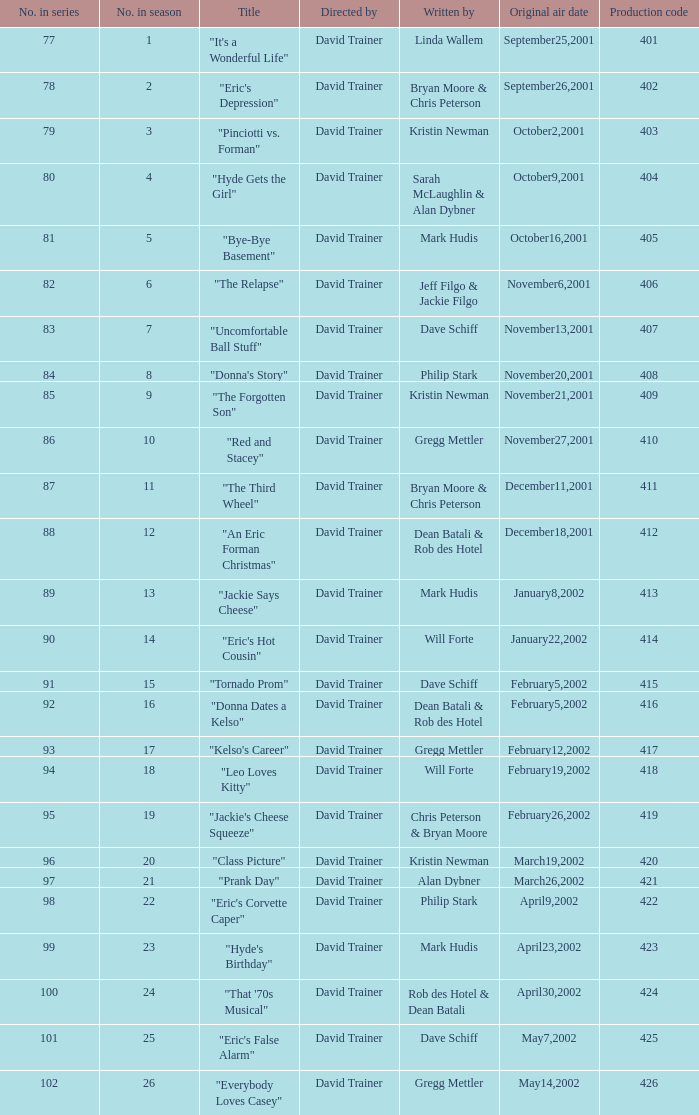How many production codes amounted to a total of 8 in the season? 1.0. 